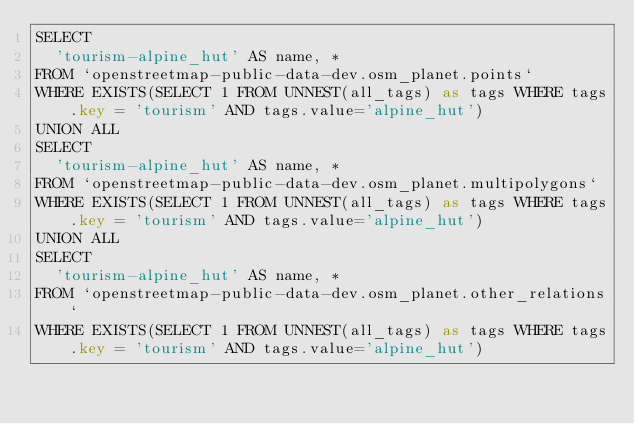Convert code to text. <code><loc_0><loc_0><loc_500><loc_500><_SQL_>SELECT
  'tourism-alpine_hut' AS name, *
FROM `openstreetmap-public-data-dev.osm_planet.points`
WHERE EXISTS(SELECT 1 FROM UNNEST(all_tags) as tags WHERE tags.key = 'tourism' AND tags.value='alpine_hut')
UNION ALL
SELECT
  'tourism-alpine_hut' AS name, *
FROM `openstreetmap-public-data-dev.osm_planet.multipolygons`
WHERE EXISTS(SELECT 1 FROM UNNEST(all_tags) as tags WHERE tags.key = 'tourism' AND tags.value='alpine_hut')
UNION ALL
SELECT
  'tourism-alpine_hut' AS name, *
FROM `openstreetmap-public-data-dev.osm_planet.other_relations`
WHERE EXISTS(SELECT 1 FROM UNNEST(all_tags) as tags WHERE tags.key = 'tourism' AND tags.value='alpine_hut')

</code> 